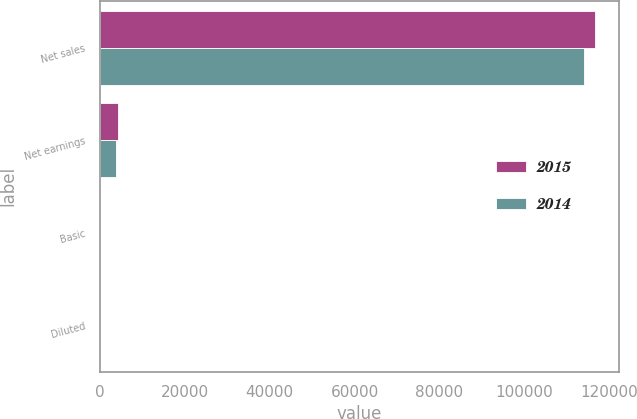Convert chart. <chart><loc_0><loc_0><loc_500><loc_500><stacked_bar_chart><ecel><fcel>Net sales<fcel>Net earnings<fcel>Basic<fcel>Diluted<nl><fcel>2015<fcel>116491<fcel>4278<fcel>4.1<fcel>4.06<nl><fcel>2014<fcel>113896<fcel>3884<fcel>3.54<fcel>3.5<nl></chart> 